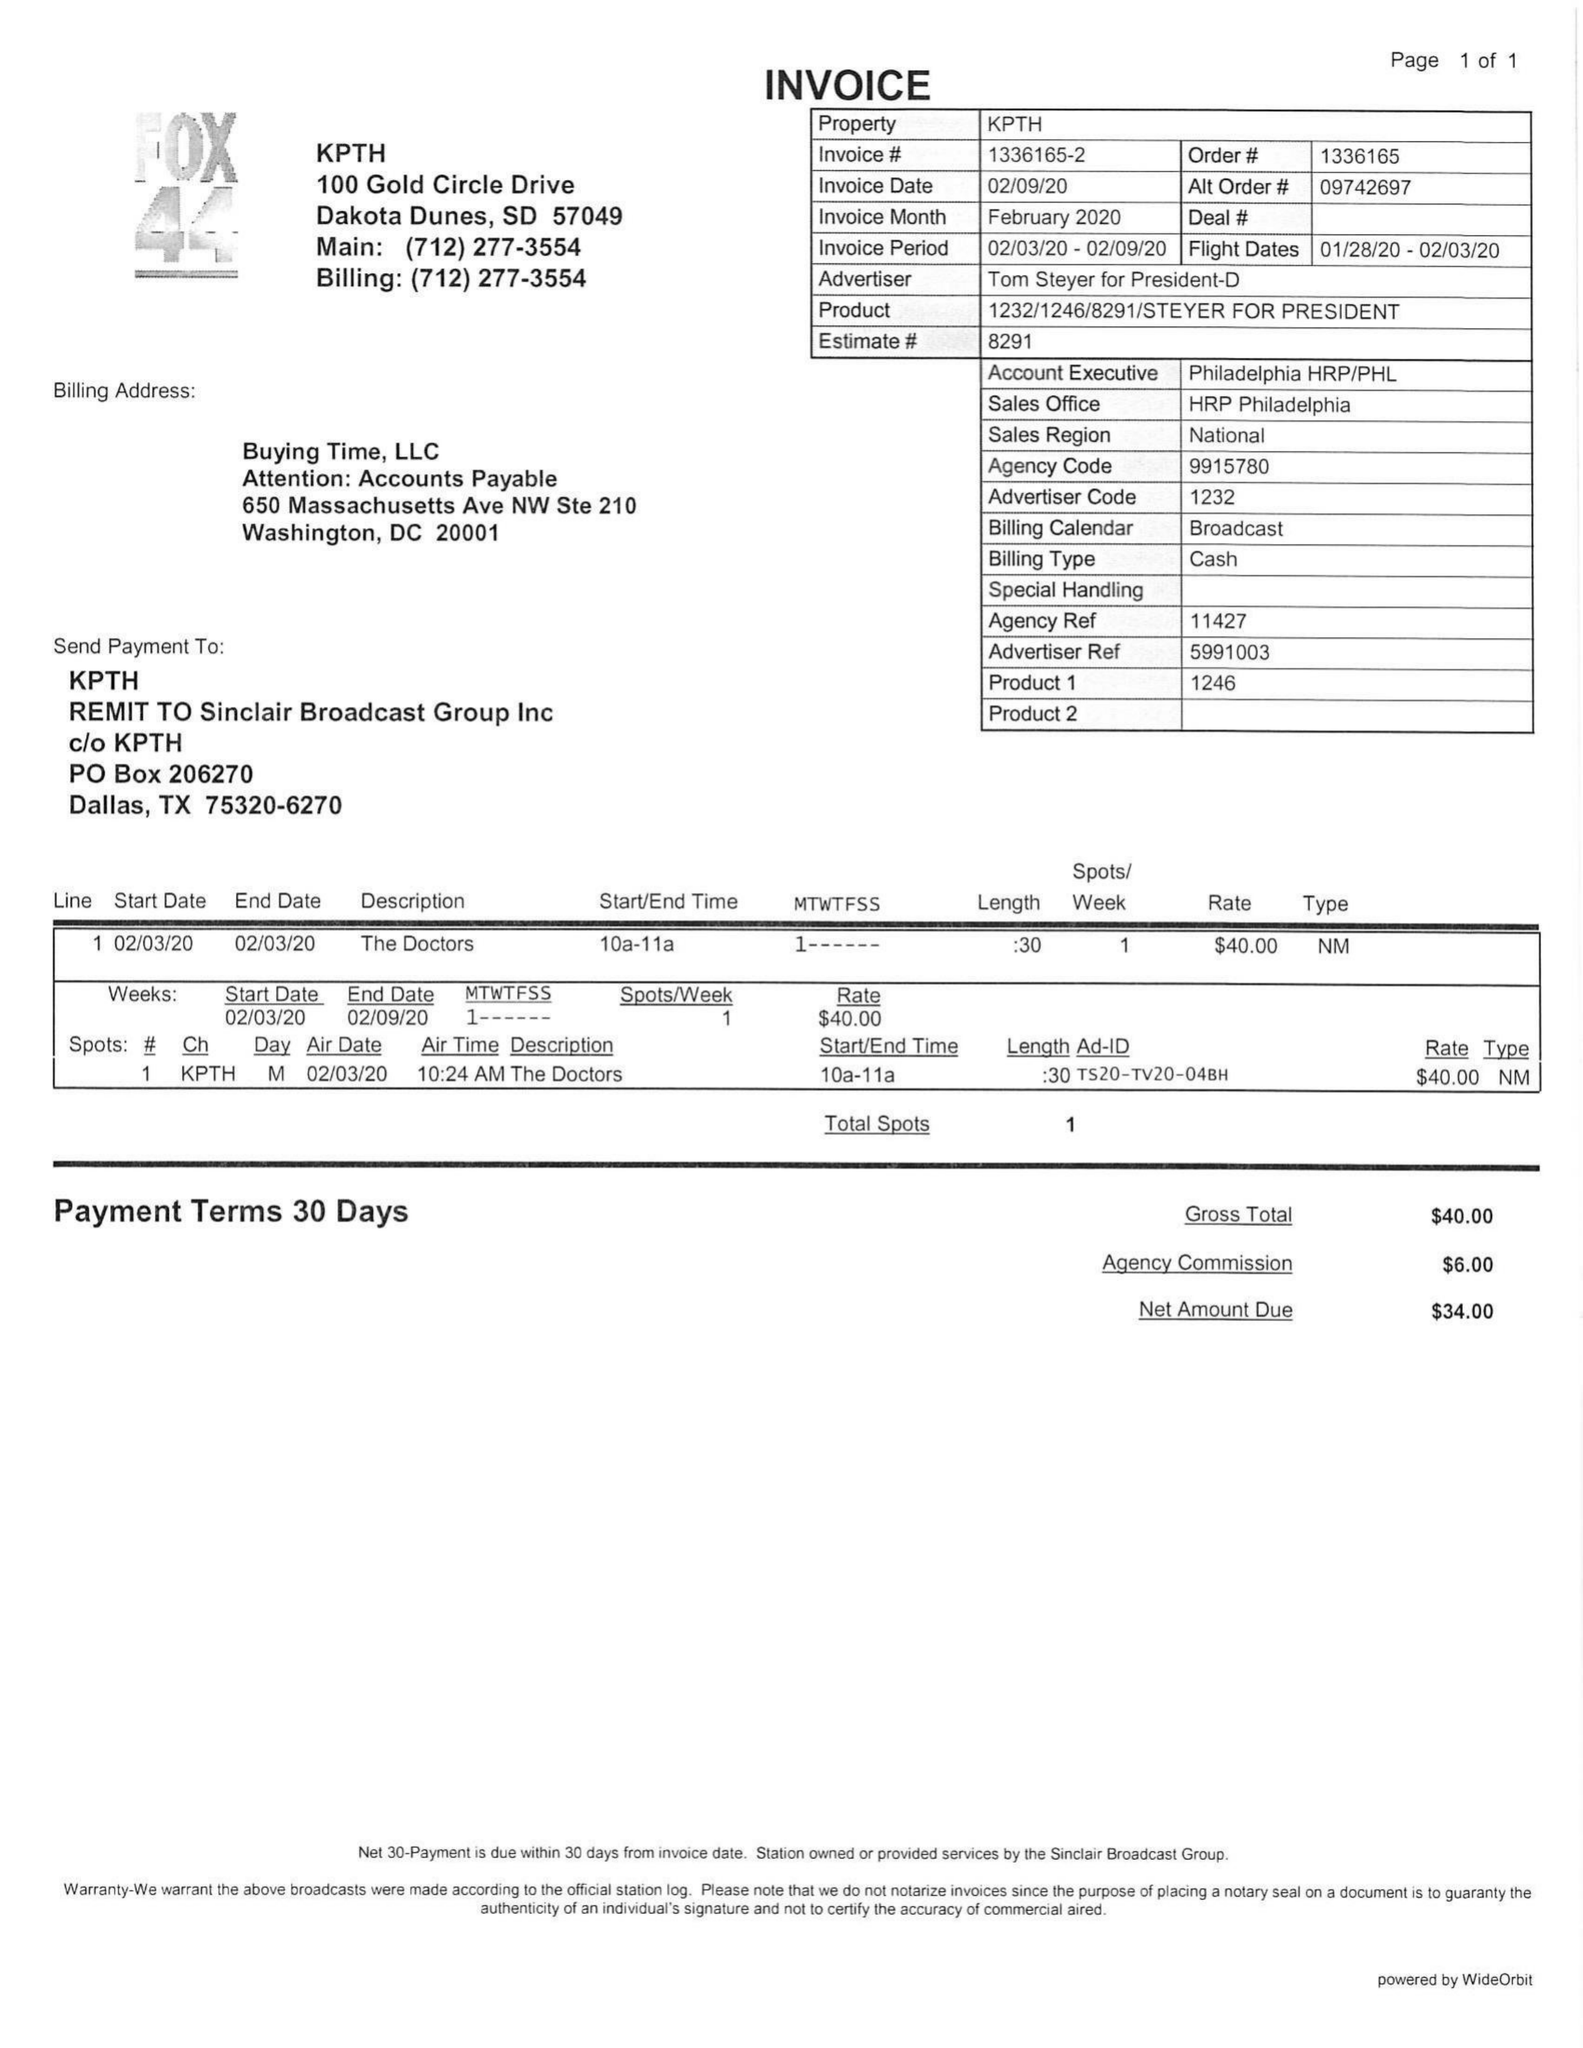What is the value for the contract_num?
Answer the question using a single word or phrase. 1336165 